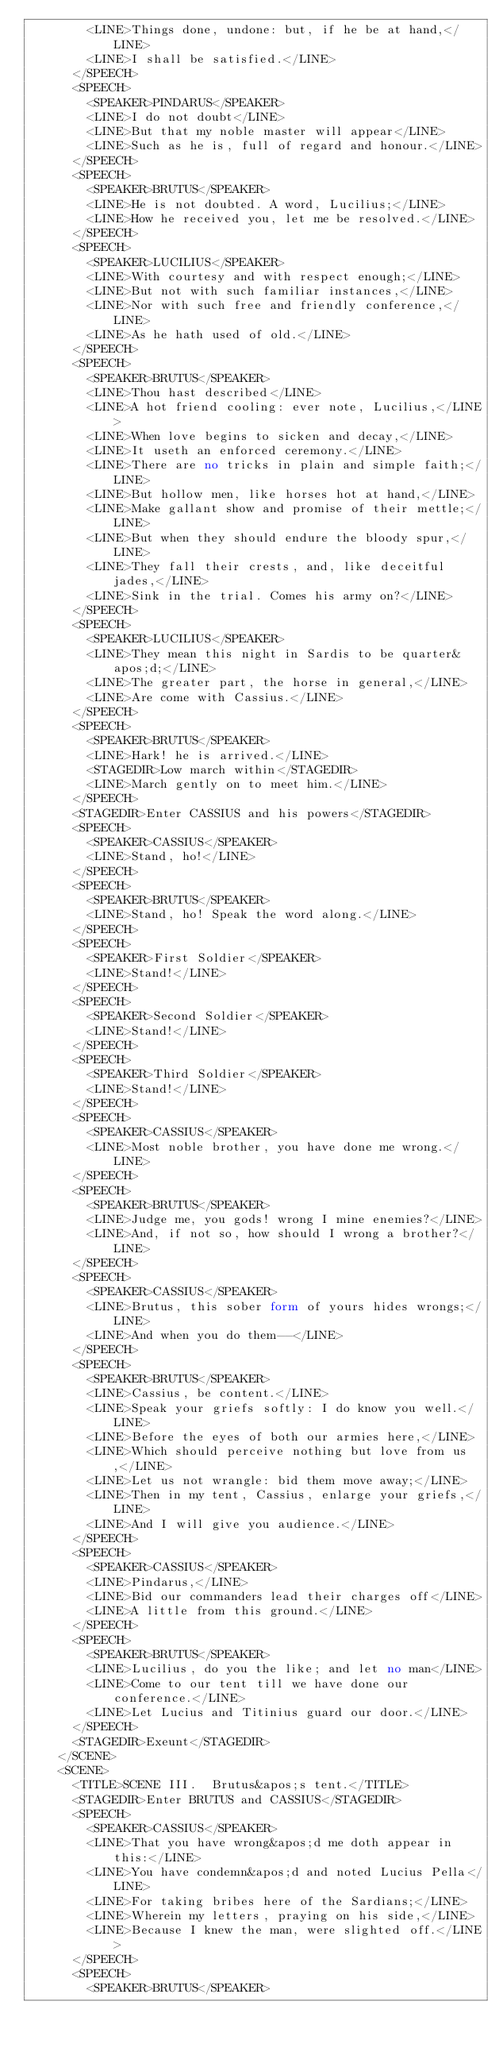Convert code to text. <code><loc_0><loc_0><loc_500><loc_500><_XML_>        <LINE>Things done, undone: but, if he be at hand,</LINE>
        <LINE>I shall be satisfied.</LINE>
      </SPEECH>
      <SPEECH>
        <SPEAKER>PINDARUS</SPEAKER>
        <LINE>I do not doubt</LINE>
        <LINE>But that my noble master will appear</LINE>
        <LINE>Such as he is, full of regard and honour.</LINE>
      </SPEECH>
      <SPEECH>
        <SPEAKER>BRUTUS</SPEAKER>
        <LINE>He is not doubted. A word, Lucilius;</LINE>
        <LINE>How he received you, let me be resolved.</LINE>
      </SPEECH>
      <SPEECH>
        <SPEAKER>LUCILIUS</SPEAKER>
        <LINE>With courtesy and with respect enough;</LINE>
        <LINE>But not with such familiar instances,</LINE>
        <LINE>Nor with such free and friendly conference,</LINE>
        <LINE>As he hath used of old.</LINE>
      </SPEECH>
      <SPEECH>
        <SPEAKER>BRUTUS</SPEAKER>
        <LINE>Thou hast described</LINE>
        <LINE>A hot friend cooling: ever note, Lucilius,</LINE>
        <LINE>When love begins to sicken and decay,</LINE>
        <LINE>It useth an enforced ceremony.</LINE>
        <LINE>There are no tricks in plain and simple faith;</LINE>
        <LINE>But hollow men, like horses hot at hand,</LINE>
        <LINE>Make gallant show and promise of their mettle;</LINE>
        <LINE>But when they should endure the bloody spur,</LINE>
        <LINE>They fall their crests, and, like deceitful jades,</LINE>
        <LINE>Sink in the trial. Comes his army on?</LINE>
      </SPEECH>
      <SPEECH>
        <SPEAKER>LUCILIUS</SPEAKER>
        <LINE>They mean this night in Sardis to be quarter&apos;d;</LINE>
        <LINE>The greater part, the horse in general,</LINE>
        <LINE>Are come with Cassius.</LINE>
      </SPEECH>
      <SPEECH>
        <SPEAKER>BRUTUS</SPEAKER>
        <LINE>Hark! he is arrived.</LINE>
        <STAGEDIR>Low march within</STAGEDIR>
        <LINE>March gently on to meet him.</LINE>
      </SPEECH>
      <STAGEDIR>Enter CASSIUS and his powers</STAGEDIR>
      <SPEECH>
        <SPEAKER>CASSIUS</SPEAKER>
        <LINE>Stand, ho!</LINE>
      </SPEECH>
      <SPEECH>
        <SPEAKER>BRUTUS</SPEAKER>
        <LINE>Stand, ho! Speak the word along.</LINE>
      </SPEECH>
      <SPEECH>
        <SPEAKER>First Soldier</SPEAKER>
        <LINE>Stand!</LINE>
      </SPEECH>
      <SPEECH>
        <SPEAKER>Second Soldier</SPEAKER>
        <LINE>Stand!</LINE>
      </SPEECH>
      <SPEECH>
        <SPEAKER>Third Soldier</SPEAKER>
        <LINE>Stand!</LINE>
      </SPEECH>
      <SPEECH>
        <SPEAKER>CASSIUS</SPEAKER>
        <LINE>Most noble brother, you have done me wrong.</LINE>
      </SPEECH>
      <SPEECH>
        <SPEAKER>BRUTUS</SPEAKER>
        <LINE>Judge me, you gods! wrong I mine enemies?</LINE>
        <LINE>And, if not so, how should I wrong a brother?</LINE>
      </SPEECH>
      <SPEECH>
        <SPEAKER>CASSIUS</SPEAKER>
        <LINE>Brutus, this sober form of yours hides wrongs;</LINE>
        <LINE>And when you do them--</LINE>
      </SPEECH>
      <SPEECH>
        <SPEAKER>BRUTUS</SPEAKER>
        <LINE>Cassius, be content.</LINE>
        <LINE>Speak your griefs softly: I do know you well.</LINE>
        <LINE>Before the eyes of both our armies here,</LINE>
        <LINE>Which should perceive nothing but love from us,</LINE>
        <LINE>Let us not wrangle: bid them move away;</LINE>
        <LINE>Then in my tent, Cassius, enlarge your griefs,</LINE>
        <LINE>And I will give you audience.</LINE>
      </SPEECH>
      <SPEECH>
        <SPEAKER>CASSIUS</SPEAKER>
        <LINE>Pindarus,</LINE>
        <LINE>Bid our commanders lead their charges off</LINE>
        <LINE>A little from this ground.</LINE>
      </SPEECH>
      <SPEECH>
        <SPEAKER>BRUTUS</SPEAKER>
        <LINE>Lucilius, do you the like; and let no man</LINE>
        <LINE>Come to our tent till we have done our conference.</LINE>
        <LINE>Let Lucius and Titinius guard our door.</LINE>
      </SPEECH>
      <STAGEDIR>Exeunt</STAGEDIR>
    </SCENE>
    <SCENE>
      <TITLE>SCENE III.  Brutus&apos;s tent.</TITLE>
      <STAGEDIR>Enter BRUTUS and CASSIUS</STAGEDIR>
      <SPEECH>
        <SPEAKER>CASSIUS</SPEAKER>
        <LINE>That you have wrong&apos;d me doth appear in this:</LINE>
        <LINE>You have condemn&apos;d and noted Lucius Pella</LINE>
        <LINE>For taking bribes here of the Sardians;</LINE>
        <LINE>Wherein my letters, praying on his side,</LINE>
        <LINE>Because I knew the man, were slighted off.</LINE>
      </SPEECH>
      <SPEECH>
        <SPEAKER>BRUTUS</SPEAKER></code> 